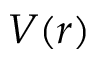Convert formula to latex. <formula><loc_0><loc_0><loc_500><loc_500>V ( r )</formula> 